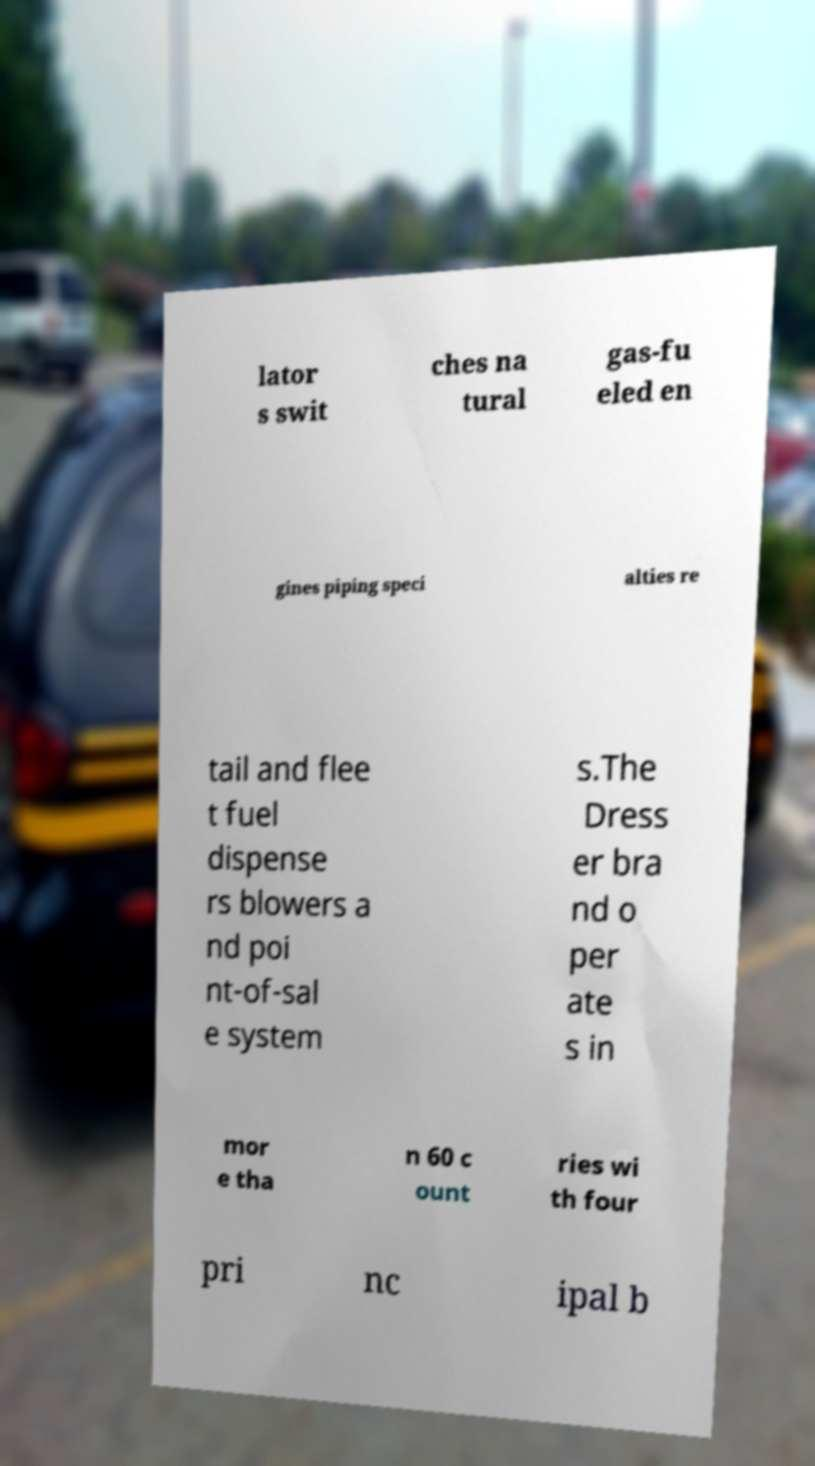Please identify and transcribe the text found in this image. lator s swit ches na tural gas-fu eled en gines piping speci alties re tail and flee t fuel dispense rs blowers a nd poi nt-of-sal e system s.The Dress er bra nd o per ate s in mor e tha n 60 c ount ries wi th four pri nc ipal b 